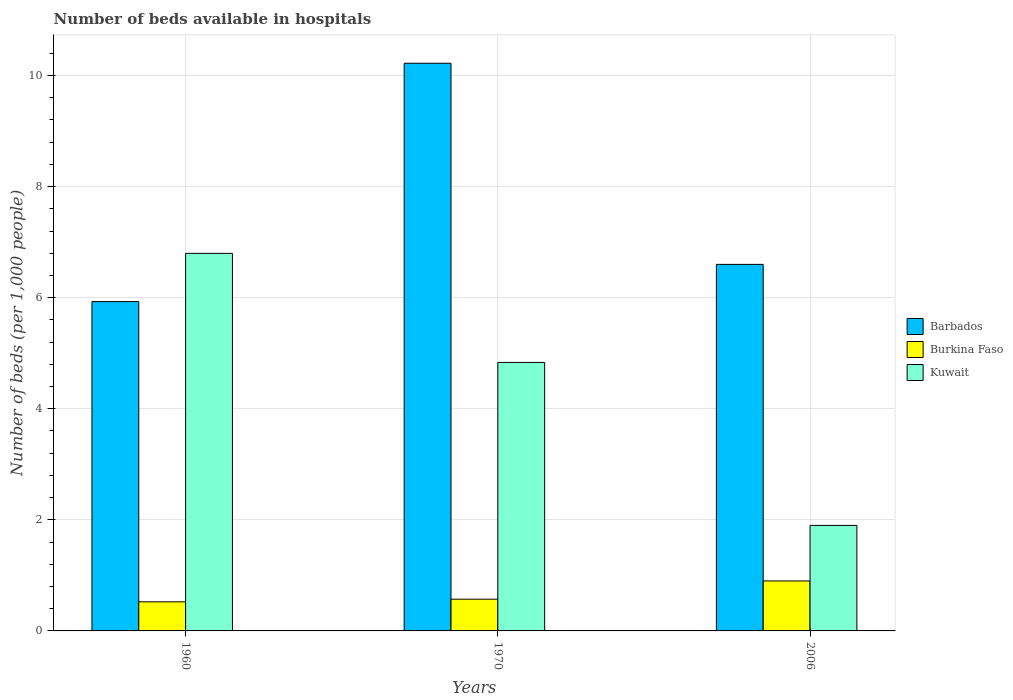How many different coloured bars are there?
Keep it short and to the point. 3. How many groups of bars are there?
Your response must be concise. 3. Are the number of bars on each tick of the X-axis equal?
Keep it short and to the point. Yes. How many bars are there on the 2nd tick from the right?
Ensure brevity in your answer.  3. In how many cases, is the number of bars for a given year not equal to the number of legend labels?
Offer a terse response. 0. What is the number of beds in the hospiatls of in Kuwait in 1960?
Offer a very short reply. 6.8. Across all years, what is the minimum number of beds in the hospiatls of in Barbados?
Your answer should be compact. 5.93. In which year was the number of beds in the hospiatls of in Burkina Faso maximum?
Offer a very short reply. 2006. What is the total number of beds in the hospiatls of in Barbados in the graph?
Your response must be concise. 22.75. What is the difference between the number of beds in the hospiatls of in Kuwait in 1960 and that in 1970?
Offer a terse response. 1.96. What is the difference between the number of beds in the hospiatls of in Kuwait in 2006 and the number of beds in the hospiatls of in Barbados in 1960?
Ensure brevity in your answer.  -4.03. What is the average number of beds in the hospiatls of in Burkina Faso per year?
Your answer should be very brief. 0.67. In the year 2006, what is the difference between the number of beds in the hospiatls of in Burkina Faso and number of beds in the hospiatls of in Barbados?
Your answer should be very brief. -5.7. What is the ratio of the number of beds in the hospiatls of in Barbados in 1970 to that in 2006?
Offer a very short reply. 1.55. Is the number of beds in the hospiatls of in Kuwait in 1960 less than that in 2006?
Your response must be concise. No. Is the difference between the number of beds in the hospiatls of in Burkina Faso in 1970 and 2006 greater than the difference between the number of beds in the hospiatls of in Barbados in 1970 and 2006?
Provide a succinct answer. No. What is the difference between the highest and the second highest number of beds in the hospiatls of in Kuwait?
Your answer should be very brief. 1.96. What is the difference between the highest and the lowest number of beds in the hospiatls of in Barbados?
Provide a short and direct response. 4.29. Is the sum of the number of beds in the hospiatls of in Barbados in 1960 and 1970 greater than the maximum number of beds in the hospiatls of in Burkina Faso across all years?
Your answer should be very brief. Yes. What does the 1st bar from the left in 2006 represents?
Keep it short and to the point. Barbados. What does the 2nd bar from the right in 1970 represents?
Ensure brevity in your answer.  Burkina Faso. Is it the case that in every year, the sum of the number of beds in the hospiatls of in Kuwait and number of beds in the hospiatls of in Barbados is greater than the number of beds in the hospiatls of in Burkina Faso?
Your answer should be very brief. Yes. How many bars are there?
Provide a succinct answer. 9. Are all the bars in the graph horizontal?
Offer a very short reply. No. How many years are there in the graph?
Provide a succinct answer. 3. What is the difference between two consecutive major ticks on the Y-axis?
Provide a succinct answer. 2. Does the graph contain any zero values?
Provide a short and direct response. No. Does the graph contain grids?
Provide a short and direct response. Yes. How are the legend labels stacked?
Your response must be concise. Vertical. What is the title of the graph?
Make the answer very short. Number of beds available in hospitals. Does "Guinea-Bissau" appear as one of the legend labels in the graph?
Give a very brief answer. No. What is the label or title of the X-axis?
Your response must be concise. Years. What is the label or title of the Y-axis?
Your answer should be very brief. Number of beds (per 1,0 people). What is the Number of beds (per 1,000 people) of Barbados in 1960?
Give a very brief answer. 5.93. What is the Number of beds (per 1,000 people) in Burkina Faso in 1960?
Give a very brief answer. 0.52. What is the Number of beds (per 1,000 people) in Kuwait in 1960?
Your response must be concise. 6.8. What is the Number of beds (per 1,000 people) in Barbados in 1970?
Provide a short and direct response. 10.22. What is the Number of beds (per 1,000 people) of Burkina Faso in 1970?
Provide a succinct answer. 0.57. What is the Number of beds (per 1,000 people) in Kuwait in 1970?
Provide a short and direct response. 4.83. What is the Number of beds (per 1,000 people) in Barbados in 2006?
Make the answer very short. 6.6. What is the Number of beds (per 1,000 people) in Kuwait in 2006?
Your response must be concise. 1.9. Across all years, what is the maximum Number of beds (per 1,000 people) in Barbados?
Offer a very short reply. 10.22. Across all years, what is the maximum Number of beds (per 1,000 people) in Burkina Faso?
Give a very brief answer. 0.9. Across all years, what is the maximum Number of beds (per 1,000 people) in Kuwait?
Provide a succinct answer. 6.8. Across all years, what is the minimum Number of beds (per 1,000 people) of Barbados?
Provide a short and direct response. 5.93. Across all years, what is the minimum Number of beds (per 1,000 people) of Burkina Faso?
Your response must be concise. 0.52. What is the total Number of beds (per 1,000 people) of Barbados in the graph?
Provide a short and direct response. 22.75. What is the total Number of beds (per 1,000 people) of Burkina Faso in the graph?
Offer a very short reply. 2. What is the total Number of beds (per 1,000 people) in Kuwait in the graph?
Provide a short and direct response. 13.53. What is the difference between the Number of beds (per 1,000 people) of Barbados in 1960 and that in 1970?
Provide a short and direct response. -4.29. What is the difference between the Number of beds (per 1,000 people) in Burkina Faso in 1960 and that in 1970?
Offer a terse response. -0.05. What is the difference between the Number of beds (per 1,000 people) in Kuwait in 1960 and that in 1970?
Your answer should be compact. 1.96. What is the difference between the Number of beds (per 1,000 people) in Barbados in 1960 and that in 2006?
Offer a terse response. -0.67. What is the difference between the Number of beds (per 1,000 people) of Burkina Faso in 1960 and that in 2006?
Make the answer very short. -0.38. What is the difference between the Number of beds (per 1,000 people) in Kuwait in 1960 and that in 2006?
Give a very brief answer. 4.9. What is the difference between the Number of beds (per 1,000 people) of Barbados in 1970 and that in 2006?
Give a very brief answer. 3.62. What is the difference between the Number of beds (per 1,000 people) in Burkina Faso in 1970 and that in 2006?
Your answer should be very brief. -0.33. What is the difference between the Number of beds (per 1,000 people) in Kuwait in 1970 and that in 2006?
Your answer should be compact. 2.93. What is the difference between the Number of beds (per 1,000 people) of Barbados in 1960 and the Number of beds (per 1,000 people) of Burkina Faso in 1970?
Provide a succinct answer. 5.36. What is the difference between the Number of beds (per 1,000 people) of Barbados in 1960 and the Number of beds (per 1,000 people) of Kuwait in 1970?
Provide a short and direct response. 1.1. What is the difference between the Number of beds (per 1,000 people) in Burkina Faso in 1960 and the Number of beds (per 1,000 people) in Kuwait in 1970?
Ensure brevity in your answer.  -4.31. What is the difference between the Number of beds (per 1,000 people) in Barbados in 1960 and the Number of beds (per 1,000 people) in Burkina Faso in 2006?
Your answer should be compact. 5.03. What is the difference between the Number of beds (per 1,000 people) in Barbados in 1960 and the Number of beds (per 1,000 people) in Kuwait in 2006?
Provide a short and direct response. 4.03. What is the difference between the Number of beds (per 1,000 people) of Burkina Faso in 1960 and the Number of beds (per 1,000 people) of Kuwait in 2006?
Give a very brief answer. -1.38. What is the difference between the Number of beds (per 1,000 people) in Barbados in 1970 and the Number of beds (per 1,000 people) in Burkina Faso in 2006?
Offer a very short reply. 9.32. What is the difference between the Number of beds (per 1,000 people) in Barbados in 1970 and the Number of beds (per 1,000 people) in Kuwait in 2006?
Offer a very short reply. 8.32. What is the difference between the Number of beds (per 1,000 people) in Burkina Faso in 1970 and the Number of beds (per 1,000 people) in Kuwait in 2006?
Ensure brevity in your answer.  -1.33. What is the average Number of beds (per 1,000 people) of Barbados per year?
Offer a terse response. 7.58. What is the average Number of beds (per 1,000 people) of Burkina Faso per year?
Offer a very short reply. 0.67. What is the average Number of beds (per 1,000 people) in Kuwait per year?
Your answer should be very brief. 4.51. In the year 1960, what is the difference between the Number of beds (per 1,000 people) of Barbados and Number of beds (per 1,000 people) of Burkina Faso?
Make the answer very short. 5.41. In the year 1960, what is the difference between the Number of beds (per 1,000 people) in Barbados and Number of beds (per 1,000 people) in Kuwait?
Your response must be concise. -0.87. In the year 1960, what is the difference between the Number of beds (per 1,000 people) of Burkina Faso and Number of beds (per 1,000 people) of Kuwait?
Ensure brevity in your answer.  -6.27. In the year 1970, what is the difference between the Number of beds (per 1,000 people) in Barbados and Number of beds (per 1,000 people) in Burkina Faso?
Provide a short and direct response. 9.65. In the year 1970, what is the difference between the Number of beds (per 1,000 people) in Barbados and Number of beds (per 1,000 people) in Kuwait?
Provide a short and direct response. 5.39. In the year 1970, what is the difference between the Number of beds (per 1,000 people) in Burkina Faso and Number of beds (per 1,000 people) in Kuwait?
Provide a succinct answer. -4.26. In the year 2006, what is the difference between the Number of beds (per 1,000 people) of Barbados and Number of beds (per 1,000 people) of Burkina Faso?
Offer a very short reply. 5.7. In the year 2006, what is the difference between the Number of beds (per 1,000 people) in Barbados and Number of beds (per 1,000 people) in Kuwait?
Your response must be concise. 4.7. What is the ratio of the Number of beds (per 1,000 people) of Barbados in 1960 to that in 1970?
Offer a very short reply. 0.58. What is the ratio of the Number of beds (per 1,000 people) of Burkina Faso in 1960 to that in 1970?
Your answer should be very brief. 0.92. What is the ratio of the Number of beds (per 1,000 people) of Kuwait in 1960 to that in 1970?
Your answer should be very brief. 1.41. What is the ratio of the Number of beds (per 1,000 people) in Barbados in 1960 to that in 2006?
Keep it short and to the point. 0.9. What is the ratio of the Number of beds (per 1,000 people) of Burkina Faso in 1960 to that in 2006?
Offer a terse response. 0.58. What is the ratio of the Number of beds (per 1,000 people) in Kuwait in 1960 to that in 2006?
Ensure brevity in your answer.  3.58. What is the ratio of the Number of beds (per 1,000 people) in Barbados in 1970 to that in 2006?
Offer a very short reply. 1.55. What is the ratio of the Number of beds (per 1,000 people) in Burkina Faso in 1970 to that in 2006?
Provide a short and direct response. 0.64. What is the ratio of the Number of beds (per 1,000 people) of Kuwait in 1970 to that in 2006?
Offer a very short reply. 2.54. What is the difference between the highest and the second highest Number of beds (per 1,000 people) of Barbados?
Your response must be concise. 3.62. What is the difference between the highest and the second highest Number of beds (per 1,000 people) of Burkina Faso?
Your response must be concise. 0.33. What is the difference between the highest and the second highest Number of beds (per 1,000 people) in Kuwait?
Offer a terse response. 1.96. What is the difference between the highest and the lowest Number of beds (per 1,000 people) of Barbados?
Give a very brief answer. 4.29. What is the difference between the highest and the lowest Number of beds (per 1,000 people) in Burkina Faso?
Your response must be concise. 0.38. What is the difference between the highest and the lowest Number of beds (per 1,000 people) of Kuwait?
Provide a short and direct response. 4.9. 